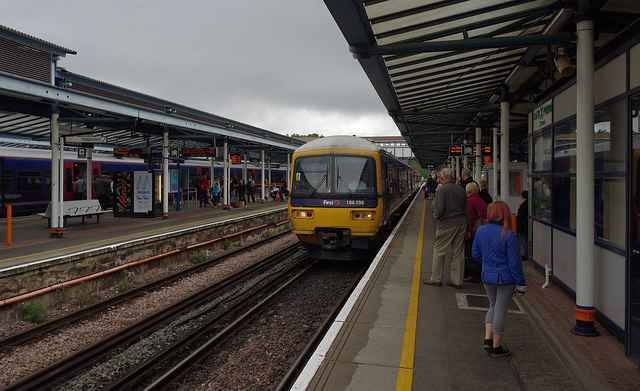Read all the text in this image. Fml 